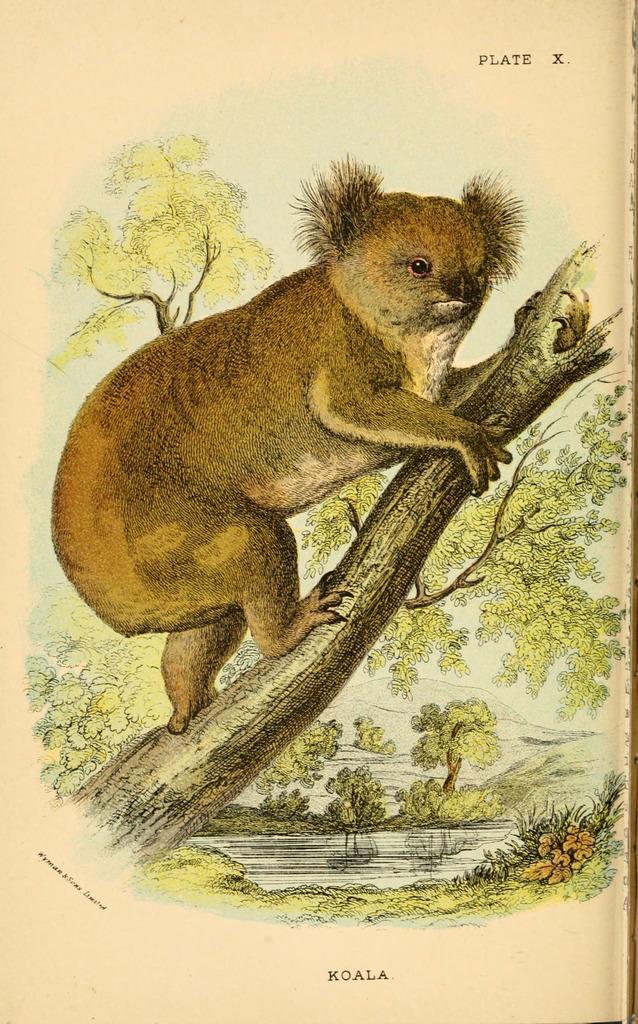Describe this image in one or two sentences. In this picture I can observe an art of an animal. This animal is koala. The background is in cream color. 